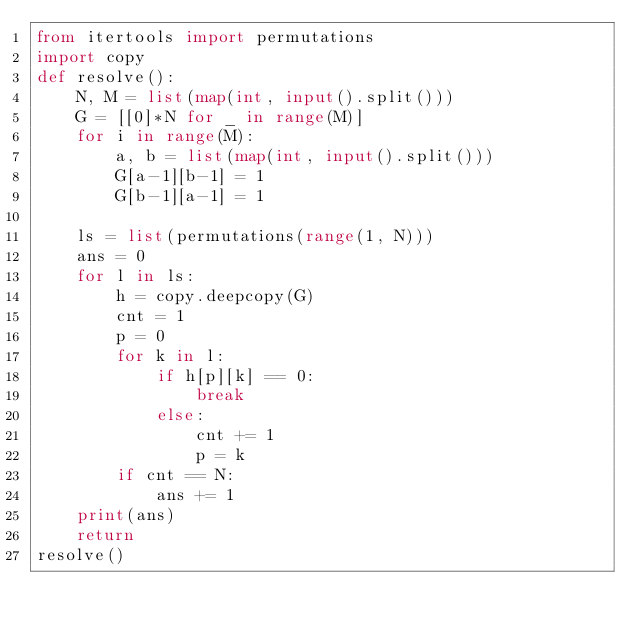Convert code to text. <code><loc_0><loc_0><loc_500><loc_500><_Python_>from itertools import permutations
import copy
def resolve():
    N, M = list(map(int, input().split()))
    G = [[0]*N for _ in range(M)]
    for i in range(M):
        a, b = list(map(int, input().split()))
        G[a-1][b-1] = 1
        G[b-1][a-1] = 1

    ls = list(permutations(range(1, N)))
    ans = 0
    for l in ls:
        h = copy.deepcopy(G)
        cnt = 1
        p = 0 
        for k in l:
            if h[p][k] == 0:
                break
            else:
                cnt += 1
                p = k
        if cnt == N:
            ans += 1
    print(ans)
    return
resolve()</code> 